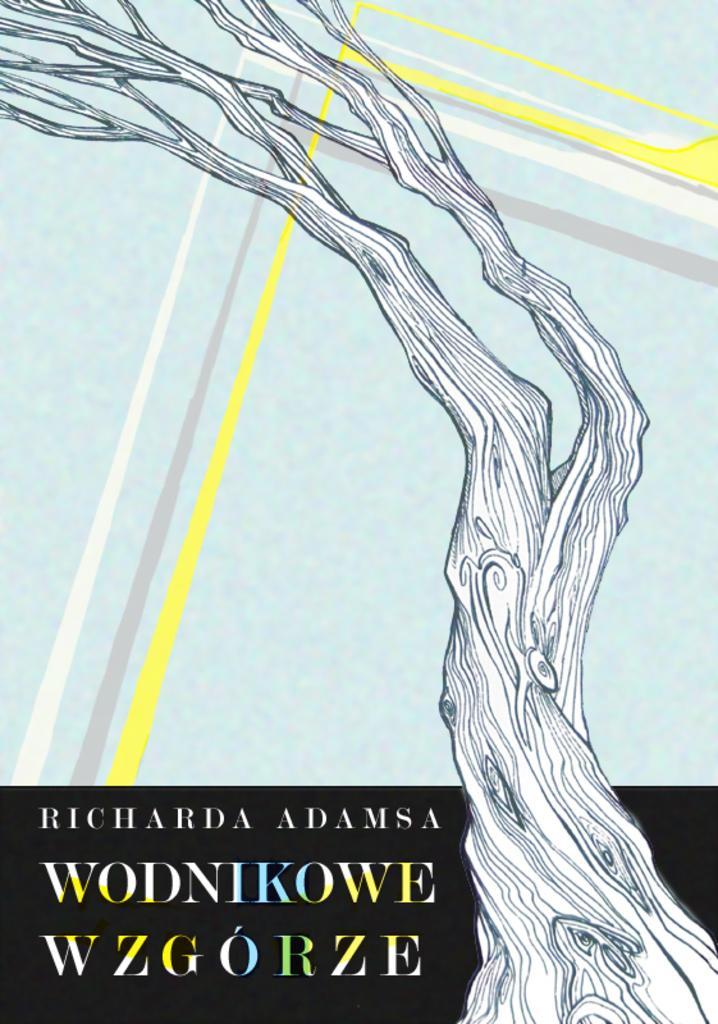Please provide a concise description of this image. This is looking like a painting, in the painting it is a branch on it is written as something. The painting is in sky blue color. 